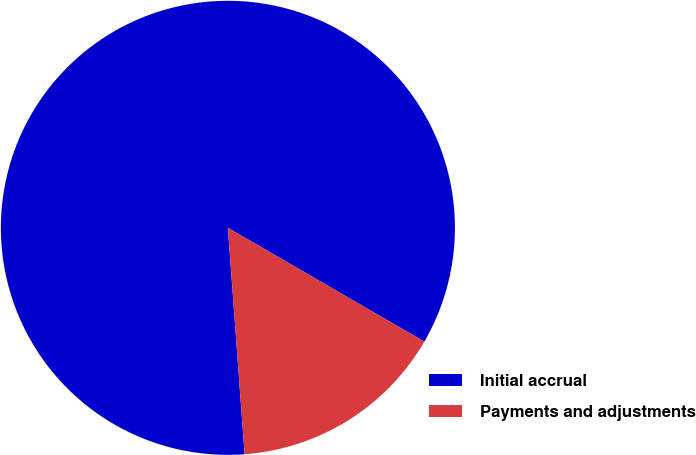Convert chart to OTSL. <chart><loc_0><loc_0><loc_500><loc_500><pie_chart><fcel>Initial accrual<fcel>Payments and adjustments<nl><fcel>84.53%<fcel>15.47%<nl></chart> 